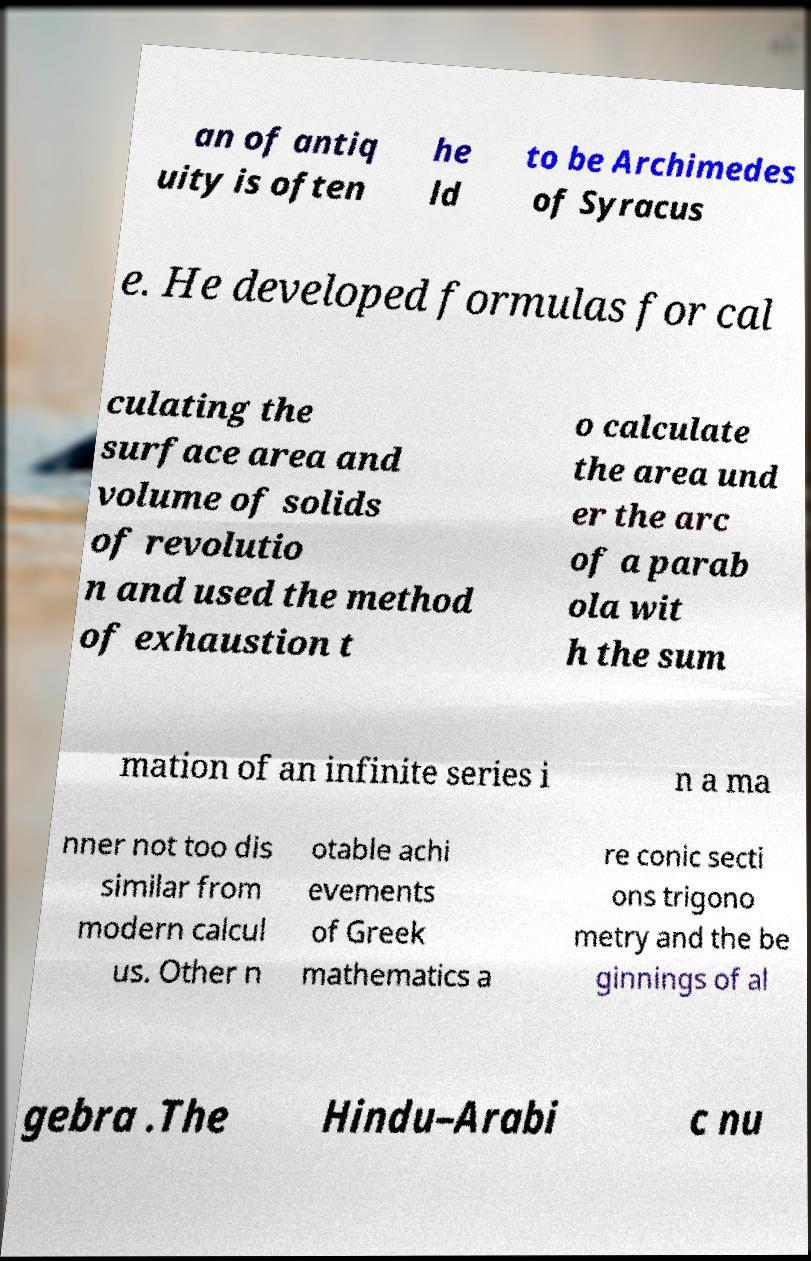Can you read and provide the text displayed in the image?This photo seems to have some interesting text. Can you extract and type it out for me? an of antiq uity is often he ld to be Archimedes of Syracus e. He developed formulas for cal culating the surface area and volume of solids of revolutio n and used the method of exhaustion t o calculate the area und er the arc of a parab ola wit h the sum mation of an infinite series i n a ma nner not too dis similar from modern calcul us. Other n otable achi evements of Greek mathematics a re conic secti ons trigono metry and the be ginnings of al gebra .The Hindu–Arabi c nu 